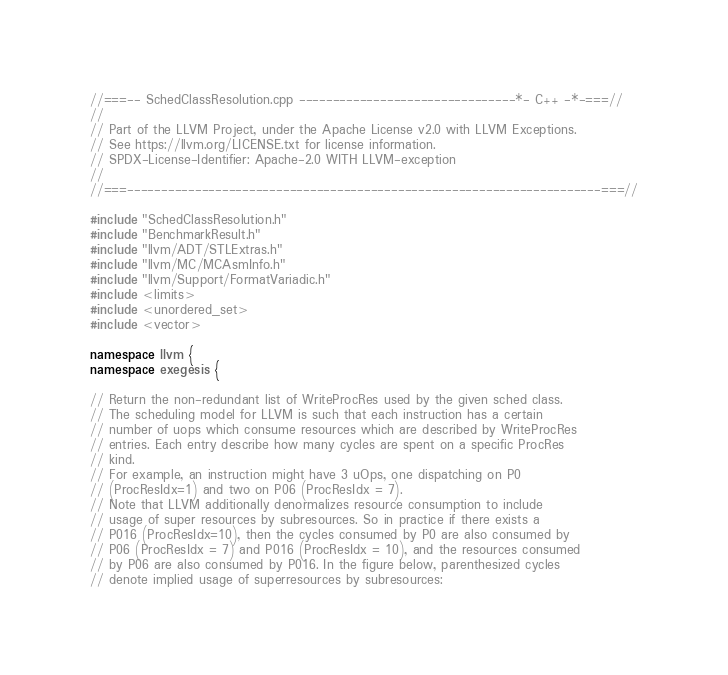Convert code to text. <code><loc_0><loc_0><loc_500><loc_500><_C++_>//===-- SchedClassResolution.cpp --------------------------------*- C++ -*-===//
//
// Part of the LLVM Project, under the Apache License v2.0 with LLVM Exceptions.
// See https://llvm.org/LICENSE.txt for license information.
// SPDX-License-Identifier: Apache-2.0 WITH LLVM-exception
//
//===----------------------------------------------------------------------===//

#include "SchedClassResolution.h"
#include "BenchmarkResult.h"
#include "llvm/ADT/STLExtras.h"
#include "llvm/MC/MCAsmInfo.h"
#include "llvm/Support/FormatVariadic.h"
#include <limits>
#include <unordered_set>
#include <vector>

namespace llvm {
namespace exegesis {

// Return the non-redundant list of WriteProcRes used by the given sched class.
// The scheduling model for LLVM is such that each instruction has a certain
// number of uops which consume resources which are described by WriteProcRes
// entries. Each entry describe how many cycles are spent on a specific ProcRes
// kind.
// For example, an instruction might have 3 uOps, one dispatching on P0
// (ProcResIdx=1) and two on P06 (ProcResIdx = 7).
// Note that LLVM additionally denormalizes resource consumption to include
// usage of super resources by subresources. So in practice if there exists a
// P016 (ProcResIdx=10), then the cycles consumed by P0 are also consumed by
// P06 (ProcResIdx = 7) and P016 (ProcResIdx = 10), and the resources consumed
// by P06 are also consumed by P016. In the figure below, parenthesized cycles
// denote implied usage of superresources by subresources:</code> 